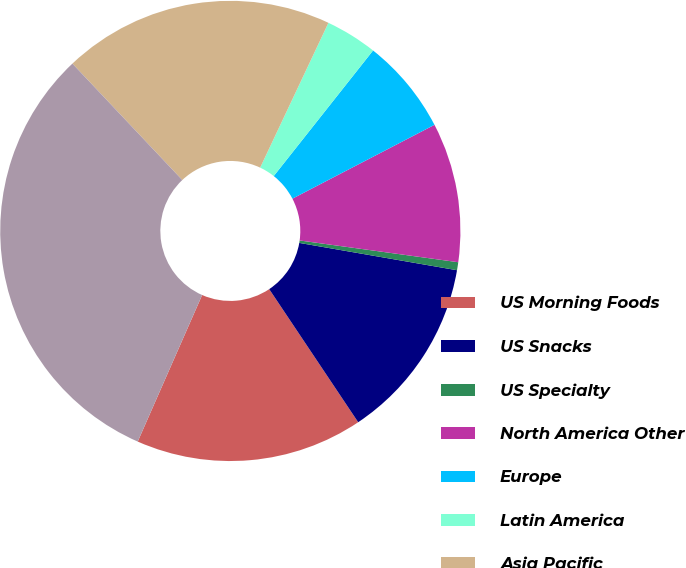<chart> <loc_0><loc_0><loc_500><loc_500><pie_chart><fcel>US Morning Foods<fcel>US Snacks<fcel>US Specialty<fcel>North America Other<fcel>Europe<fcel>Latin America<fcel>Asia Pacific<fcel>Total<nl><fcel>15.97%<fcel>12.89%<fcel>0.56%<fcel>9.8%<fcel>6.72%<fcel>3.64%<fcel>19.05%<fcel>31.37%<nl></chart> 